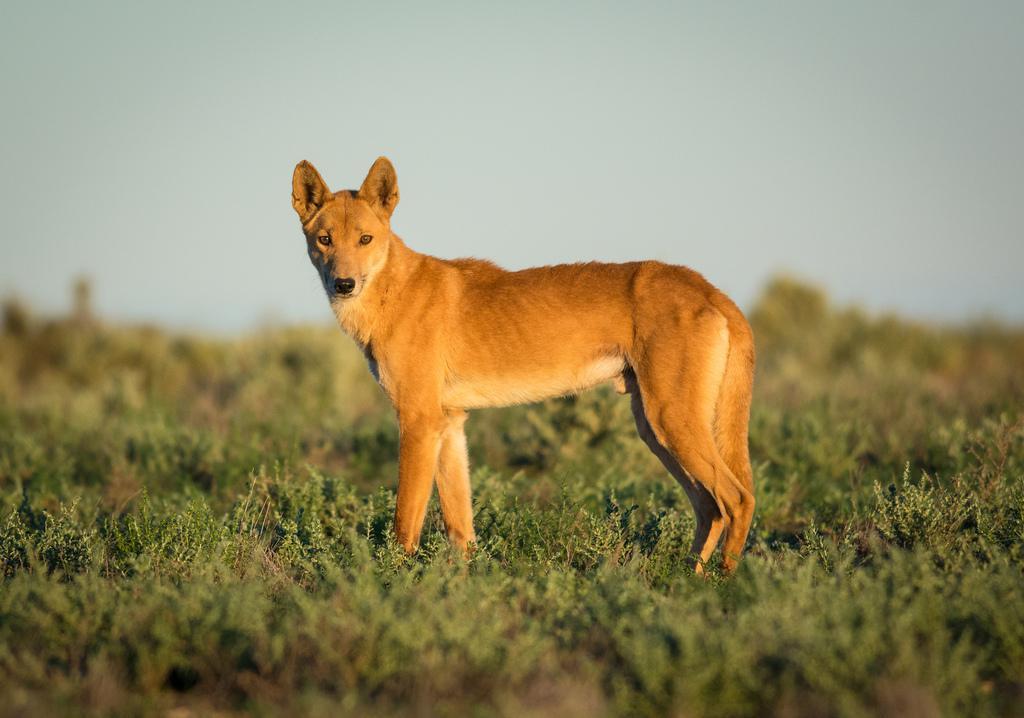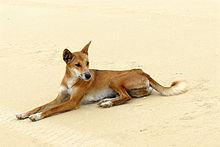The first image is the image on the left, the second image is the image on the right. For the images shown, is this caption "In the left image, a dog's eyes are narrowed because it looks sleepy." true? Answer yes or no. No. 